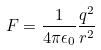Convert formula to latex. <formula><loc_0><loc_0><loc_500><loc_500>F = \frac { 1 } { 4 \pi \epsilon _ { 0 } } \frac { q ^ { 2 } } { r ^ { 2 } }</formula> 